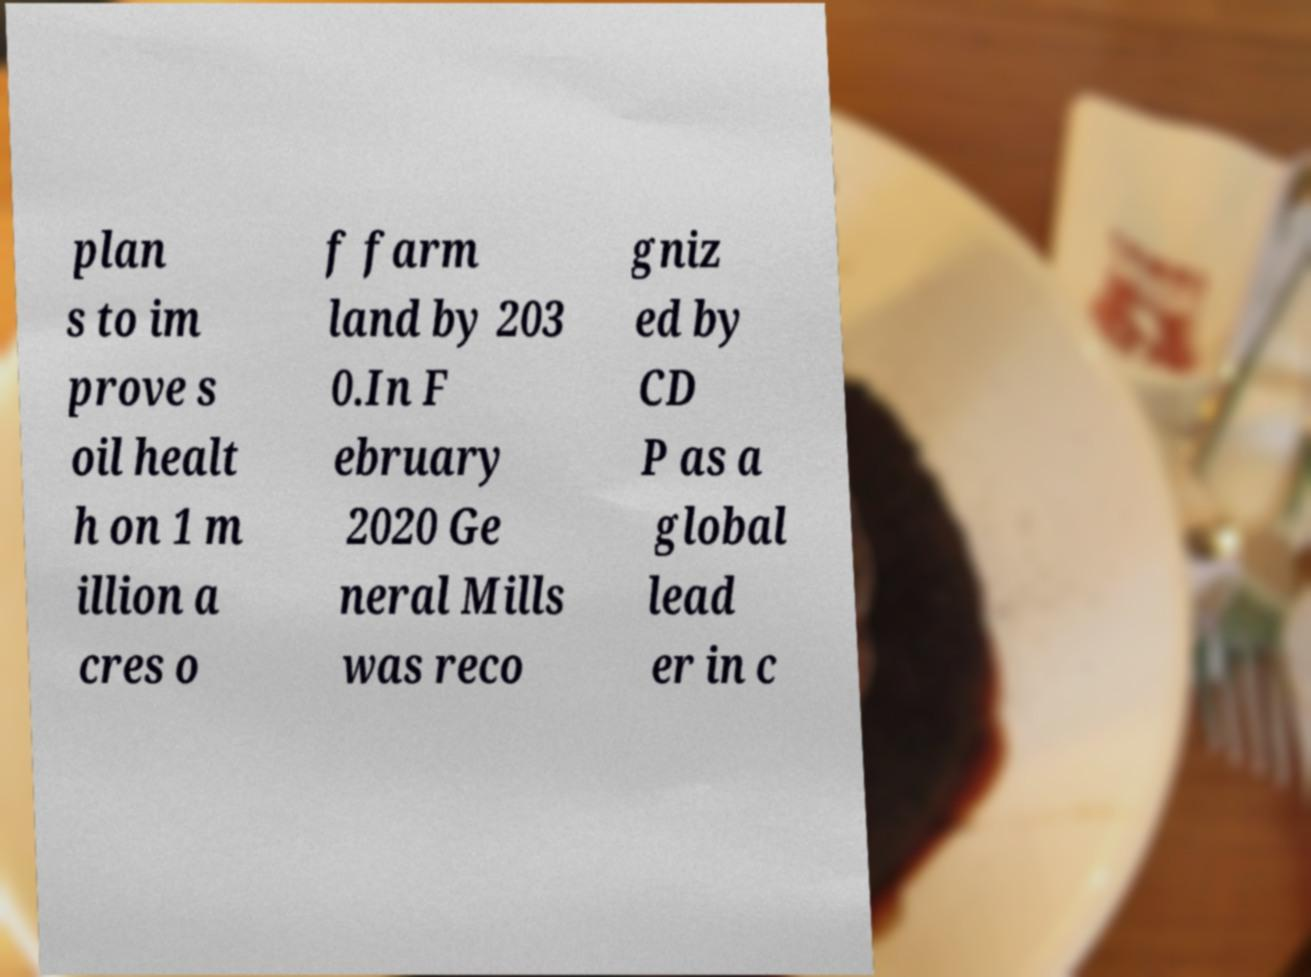What messages or text are displayed in this image? I need them in a readable, typed format. plan s to im prove s oil healt h on 1 m illion a cres o f farm land by 203 0.In F ebruary 2020 Ge neral Mills was reco gniz ed by CD P as a global lead er in c 